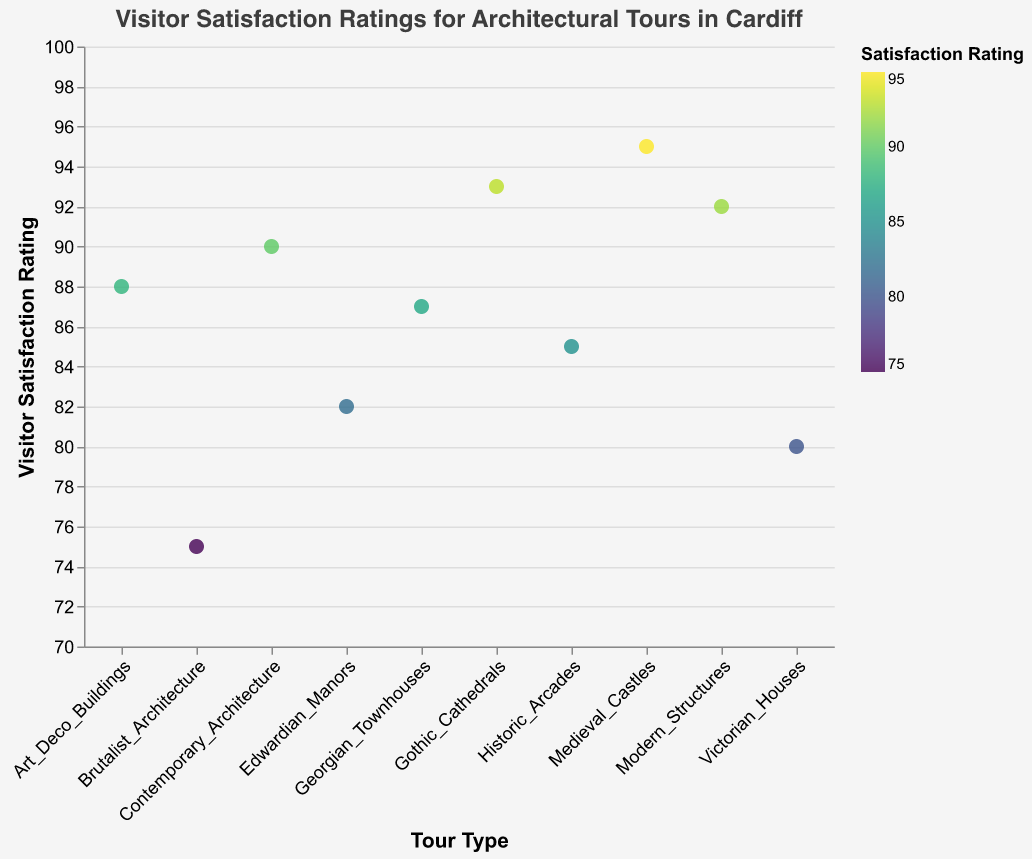Which architectural tour has the highest visitor satisfaction rating? The highest visitor satisfaction rating is visible as the highest point on the y-axis. Medieval Castles has the highest rating.
Answer: Medieval Castles Which architectural tour has the lowest visitor satisfaction rating? The lowest visitor satisfaction rating is visible as the lowest point on the y-axis. Brutalist Architecture has the lowest rating.
Answer: Brutalist Architecture What is the average visitor satisfaction rating? To find the average rating, sum all the ratings and divide by the number of tours. (85 + 90 + 95 + 80 + 88 + 92 + 82 + 87 + 75 + 93) / 10 = 86.7
Answer: 86.7 Which architectural tour types have a rating higher than 90? Identifying points on the y-axis above 90, the tours with ratings higher than 90 are Contemporary Architecture, Medieval Castles, Modern Structures, and Gothic Cathedrals.
Answer: Contemporary Architecture, Medieval Castles, Modern Structures, Gothic Cathedrals What is the difference in visitor satisfaction rating between the highest and lowest-rated tours? Subtract the lowest rating from the highest rating. 95 (highest) - 75 (lowest) = 20
Answer: 20 How many architectural tours have a visitor satisfaction rating of 88 or higher? Count the number of points on the y-axis that are 88 or higher. There are 7 tours: Historic Arcades, Contemporary Architecture, Medieval Castles, Art Deco Buildings, Modern Structures, Georgian Townhouses, Gothic Cathedrals.
Answer: 7 Is there a correlation between architectural tour type and visitor satisfaction rating? By observing the scatter plot, we can see that the visitor satisfaction ratings vary significantly across different architectural tours without a clear pattern, suggesting no strong correlation.
Answer: No strong correlation Which architectural tour has a visitor satisfaction rating closest to the average rating? The average rating is 86.7. Georgian Townhouses have a rating of 87, which is closest to the average.
Answer: Georgian Townhouses What is the visitor satisfaction rating for Gothic Cathedrals? The rating for Gothic Cathedrals can be directly read from the figure near its data point. The rating is 93.
Answer: 93 